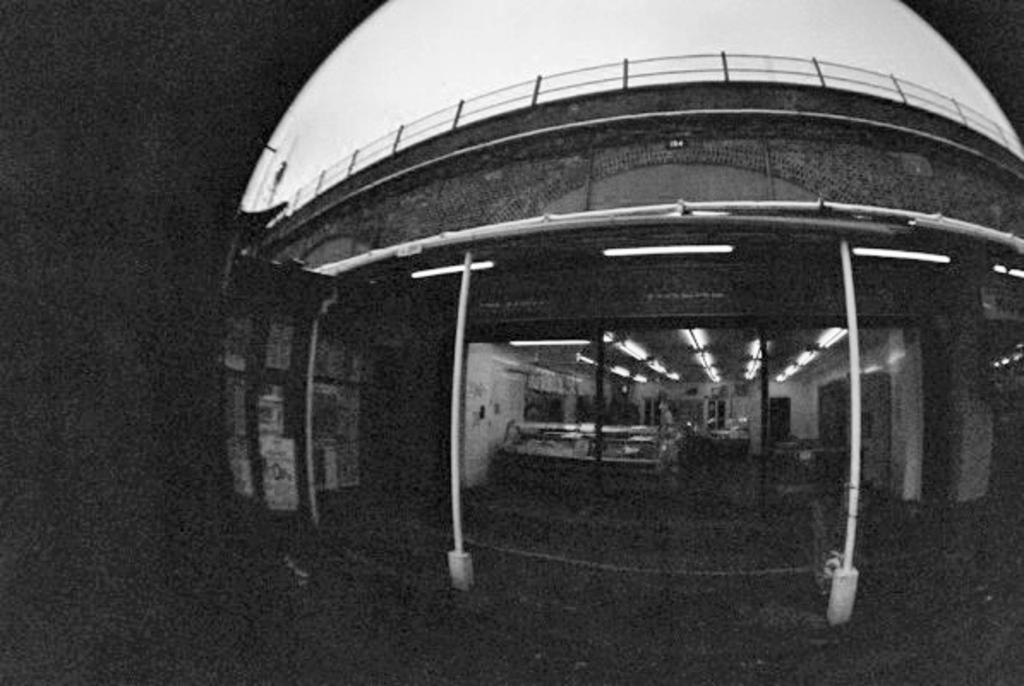Describe this image in one or two sentences. In this image I can see the building and the image is in white and black color. 